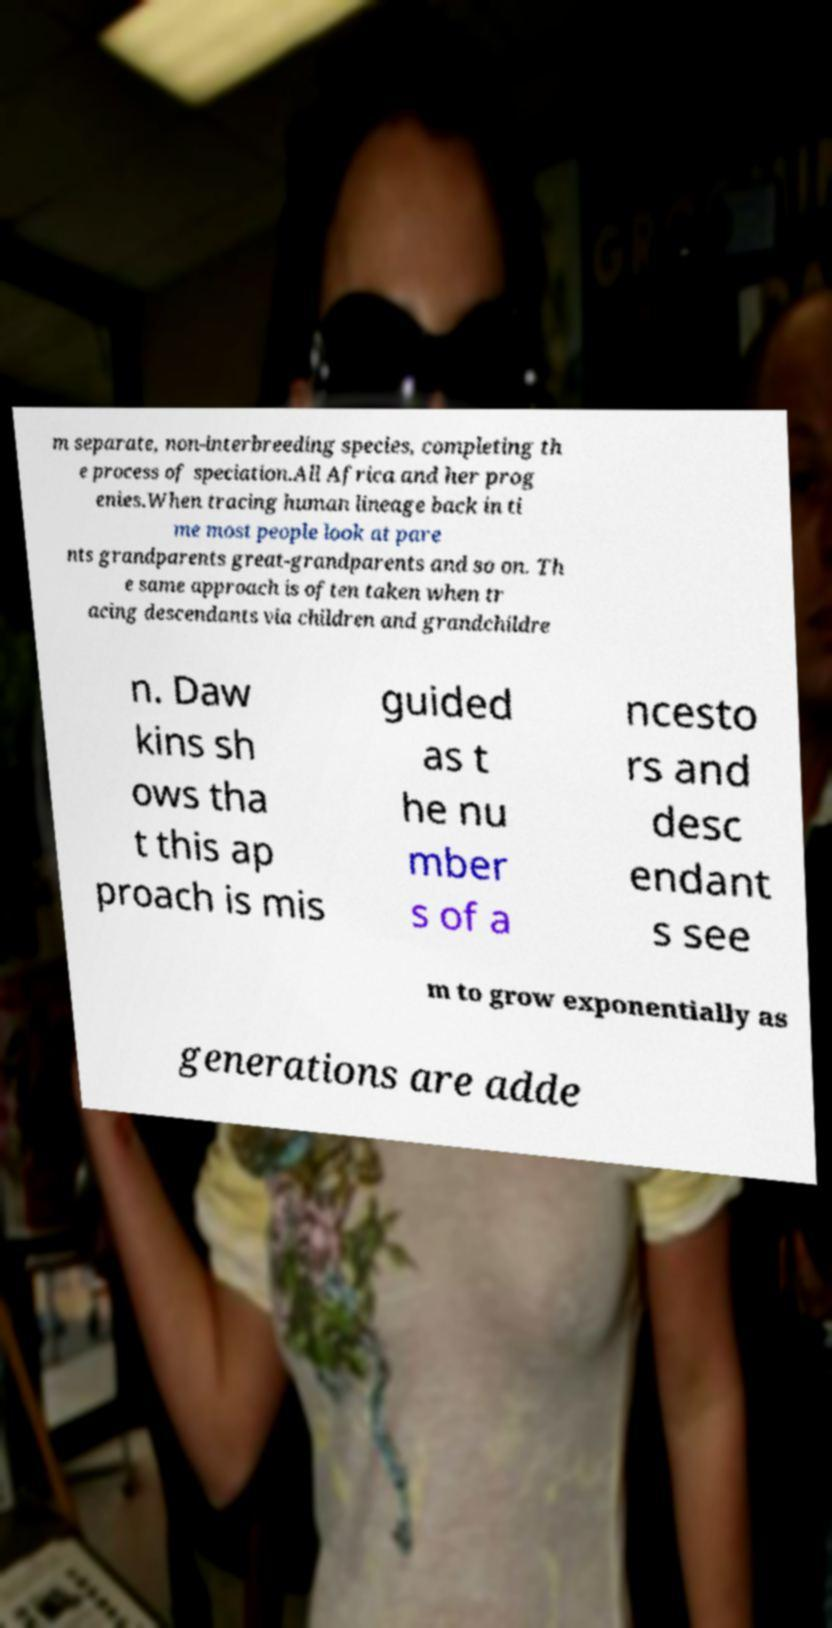I need the written content from this picture converted into text. Can you do that? m separate, non-interbreeding species, completing th e process of speciation.All Africa and her prog enies.When tracing human lineage back in ti me most people look at pare nts grandparents great-grandparents and so on. Th e same approach is often taken when tr acing descendants via children and grandchildre n. Daw kins sh ows tha t this ap proach is mis guided as t he nu mber s of a ncesto rs and desc endant s see m to grow exponentially as generations are adde 